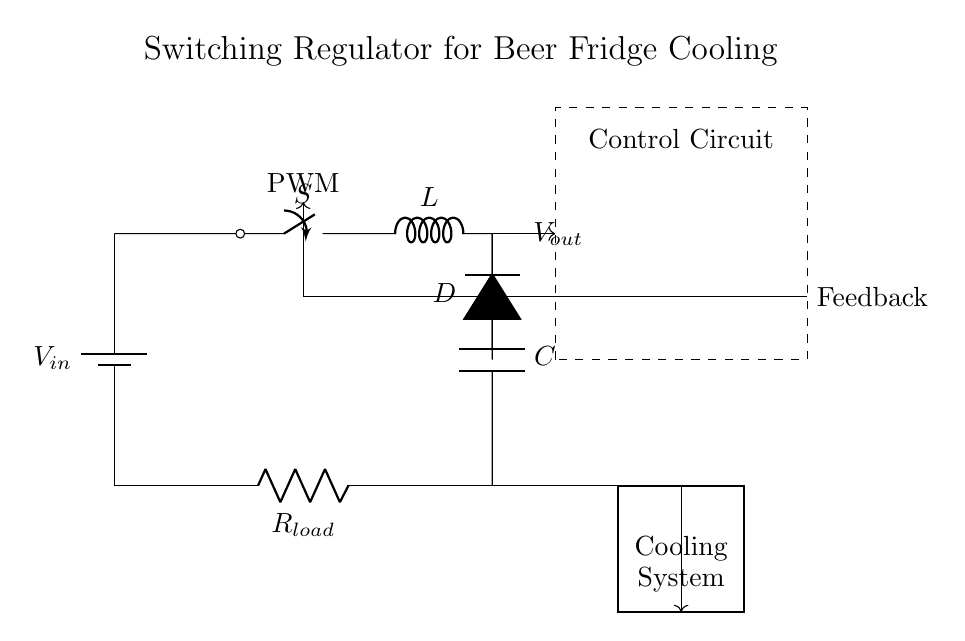What is the input voltage in the circuit? The input voltage is labeled as Vin and is positioned at the battery in the upper left corner of the diagram. Since no specific value is provided, we recognize it as an unspecified input voltage.
Answer: Vin What component is responsible for storing energy? The inductor, labeled as L, is responsible for storing energy in magnetic fields. In the diagram, it is positioned in the path of current flow, connected to the switch and diode.
Answer: L Where is the feedback signal coming from? The feedback signal originates from the output capacitor and load resistor and is directed towards the control circuit, indicated by the dash-lined connection at the top right of the diagram.
Answer: Control Circuit What role does the diode play in this circuit? The diode, labeled as D, allows current to flow in only one direction, preventing backflow from the capacitor while the switch is turned off, hence regulating the output supply efficiently.
Answer: Prevent backflow What type of control method is indicated in this circuit? The circuit prominently features a PWM (Pulse Width Modulation) control method as indicated by the annotation near the control circuit, which regulates the output voltage based on the load requirements.
Answer: PWM What is the purpose of the cooling system in the diagram? The cooling system indicated in the bottom right rectangle is designed to utilize the regulated output voltage, which in turn helps manage the temperature within the beer refrigerators effectively.
Answer: Manage temperature 